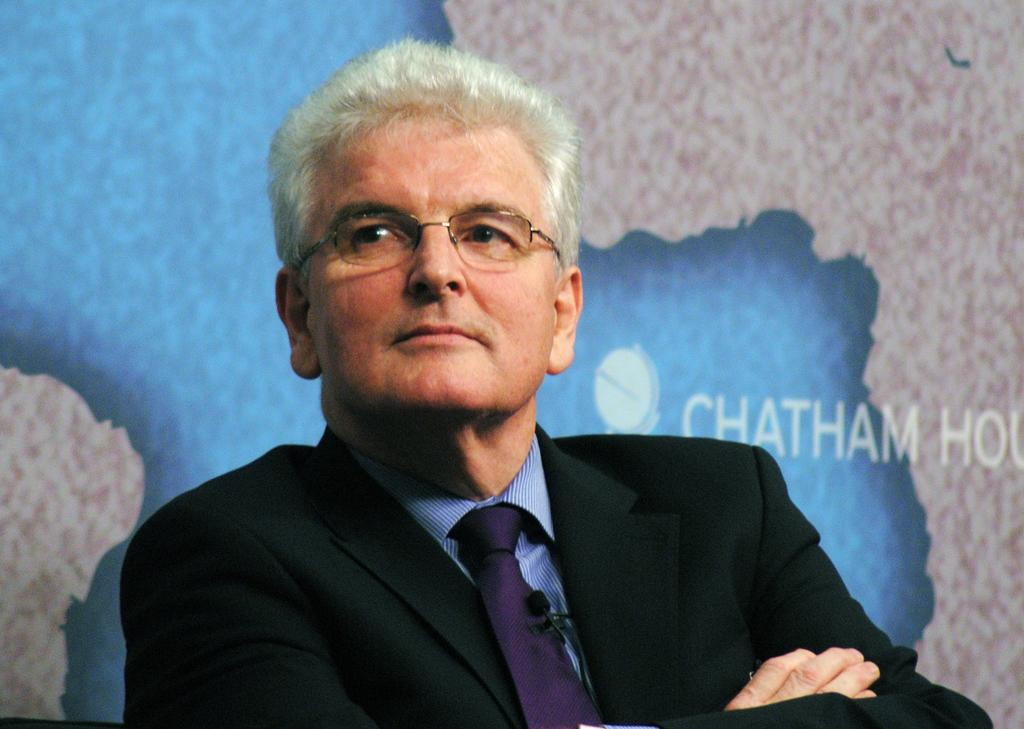Who is present in the image? There is a man in the image. What is the man wearing on his face? The man is wearing spectacles. What type of clothing is the man wearing on his upper body? The man is wearing a blazer. What type of accessory is the man wearing around his neck? The man is wearing a tie. What is the man's facial expression in the image? The man is smiling. What can be seen in the background of the image? There is a poster visible in the background of the image. What type of acoustics can be heard in the image? There is no sound or acoustics present in the image, as it is a still photograph. What fact is being presented in the image? The image does not present any specific fact; it is a picture of a man wearing a blazer, tie, and spectacles, and smiling. 